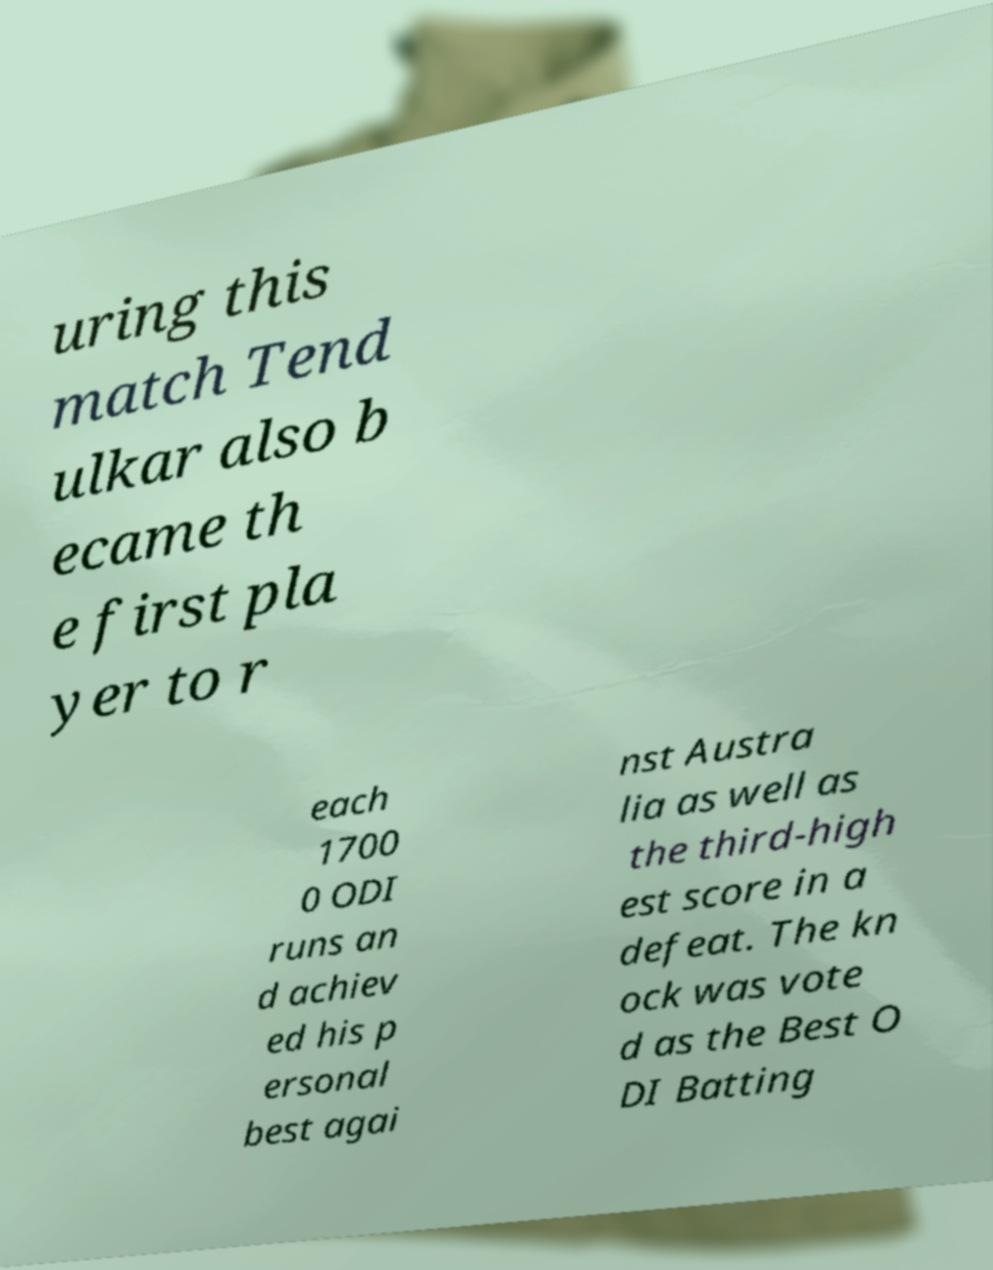Please identify and transcribe the text found in this image. uring this match Tend ulkar also b ecame th e first pla yer to r each 1700 0 ODI runs an d achiev ed his p ersonal best agai nst Austra lia as well as the third-high est score in a defeat. The kn ock was vote d as the Best O DI Batting 